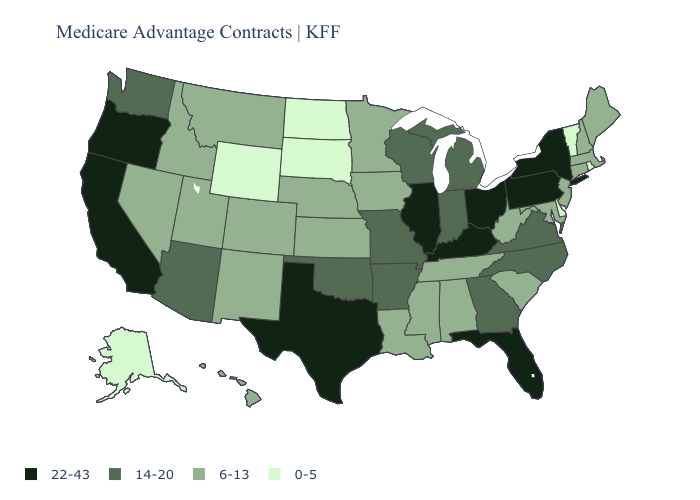Name the states that have a value in the range 14-20?
Concise answer only. Arkansas, Arizona, Georgia, Indiana, Michigan, Missouri, North Carolina, Oklahoma, Virginia, Washington, Wisconsin. Does the first symbol in the legend represent the smallest category?
Short answer required. No. Does Washington have a higher value than West Virginia?
Keep it brief. Yes. What is the value of Iowa?
Give a very brief answer. 6-13. Is the legend a continuous bar?
Short answer required. No. Among the states that border Illinois , which have the highest value?
Give a very brief answer. Kentucky. Among the states that border Louisiana , does Texas have the highest value?
Short answer required. Yes. What is the value of Illinois?
Short answer required. 22-43. What is the value of Missouri?
Short answer required. 14-20. Name the states that have a value in the range 14-20?
Give a very brief answer. Arkansas, Arizona, Georgia, Indiana, Michigan, Missouri, North Carolina, Oklahoma, Virginia, Washington, Wisconsin. What is the highest value in the West ?
Quick response, please. 22-43. What is the lowest value in states that border Utah?
Short answer required. 0-5. Does Alabama have a lower value than West Virginia?
Short answer required. No. Does Connecticut have a lower value than North Dakota?
Concise answer only. No. 